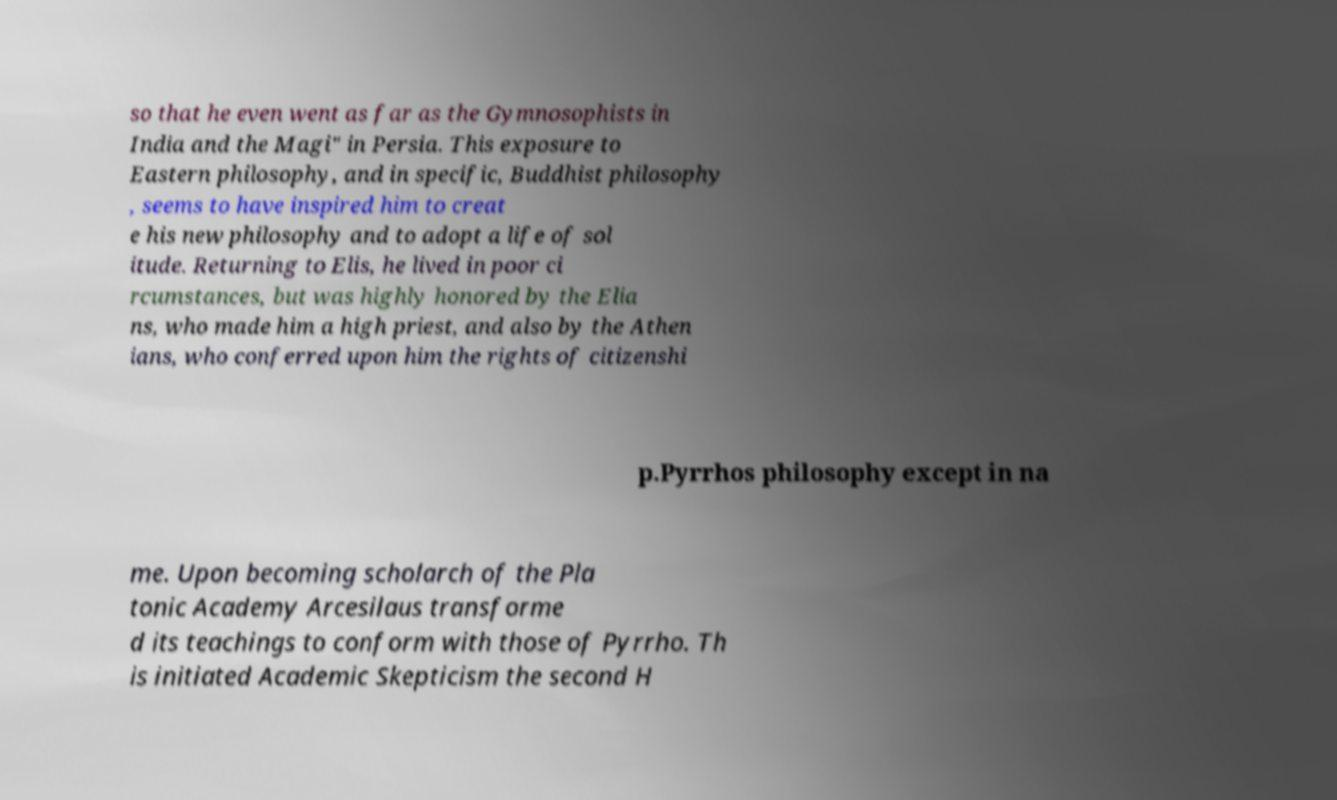Please read and relay the text visible in this image. What does it say? so that he even went as far as the Gymnosophists in India and the Magi" in Persia. This exposure to Eastern philosophy, and in specific, Buddhist philosophy , seems to have inspired him to creat e his new philosophy and to adopt a life of sol itude. Returning to Elis, he lived in poor ci rcumstances, but was highly honored by the Elia ns, who made him a high priest, and also by the Athen ians, who conferred upon him the rights of citizenshi p.Pyrrhos philosophy except in na me. Upon becoming scholarch of the Pla tonic Academy Arcesilaus transforme d its teachings to conform with those of Pyrrho. Th is initiated Academic Skepticism the second H 